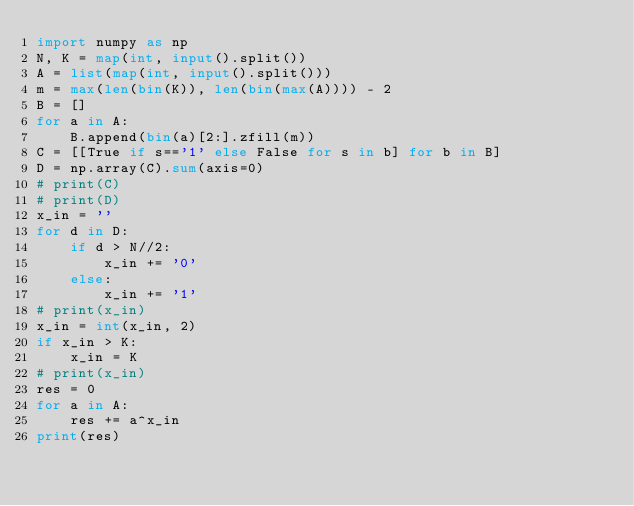Convert code to text. <code><loc_0><loc_0><loc_500><loc_500><_Python_>import numpy as np
N, K = map(int, input().split())
A = list(map(int, input().split()))
m = max(len(bin(K)), len(bin(max(A)))) - 2
B = []
for a in A:
    B.append(bin(a)[2:].zfill(m))
C = [[True if s=='1' else False for s in b] for b in B]
D = np.array(C).sum(axis=0)
# print(C)
# print(D)
x_in = ''
for d in D:
    if d > N//2:
        x_in += '0'
    else:
        x_in += '1'
# print(x_in)
x_in = int(x_in, 2)
if x_in > K:
    x_in = K
# print(x_in)
res = 0
for a in A:
    res += a^x_in
print(res)</code> 